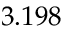Convert formula to latex. <formula><loc_0><loc_0><loc_500><loc_500>3 . 1 9 8</formula> 